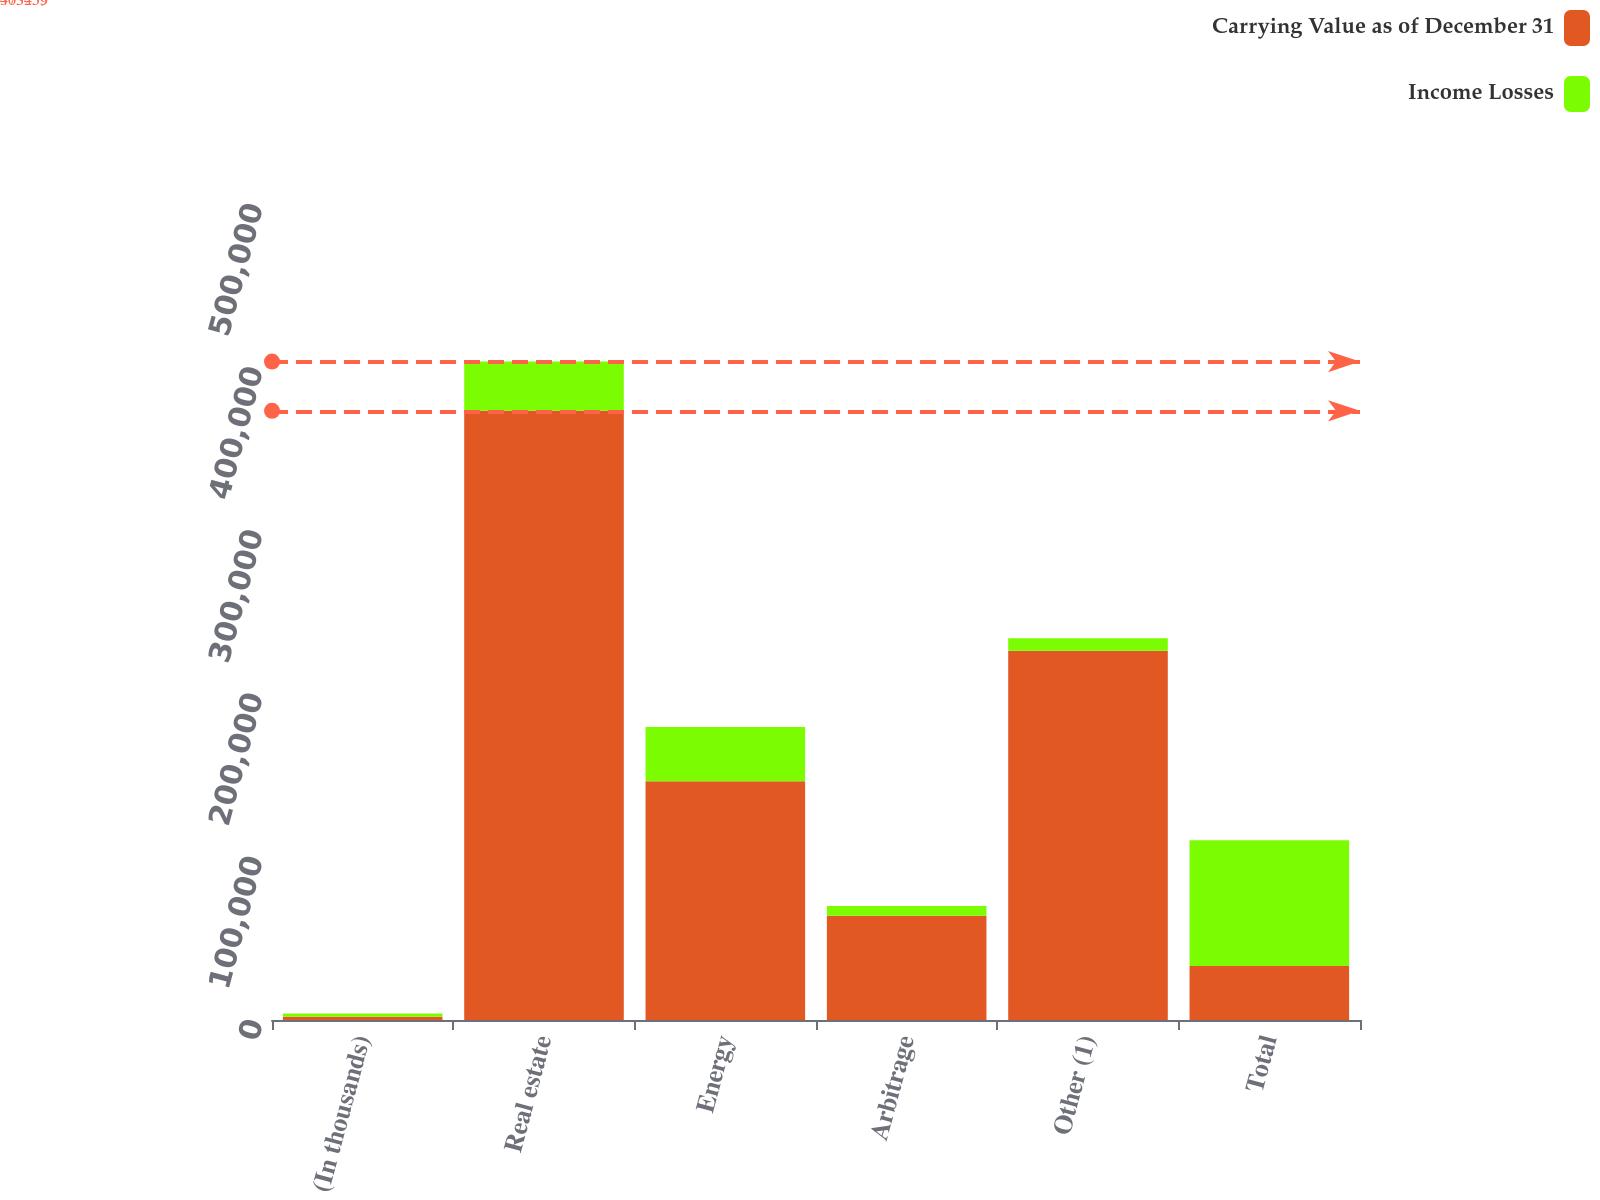<chart> <loc_0><loc_0><loc_500><loc_500><stacked_bar_chart><ecel><fcel>(In thousands)<fcel>Real estate<fcel>Energy<fcel>Arbitrage<fcel>Other (1)<fcel>Total<nl><fcel>Carrying Value as of December 31<fcel>2012<fcel>373259<fcel>146325<fcel>63920<fcel>226185<fcel>33146<nl><fcel>Income Losses<fcel>2012<fcel>30196<fcel>33146<fcel>5912<fcel>7761<fcel>77015<nl></chart> 